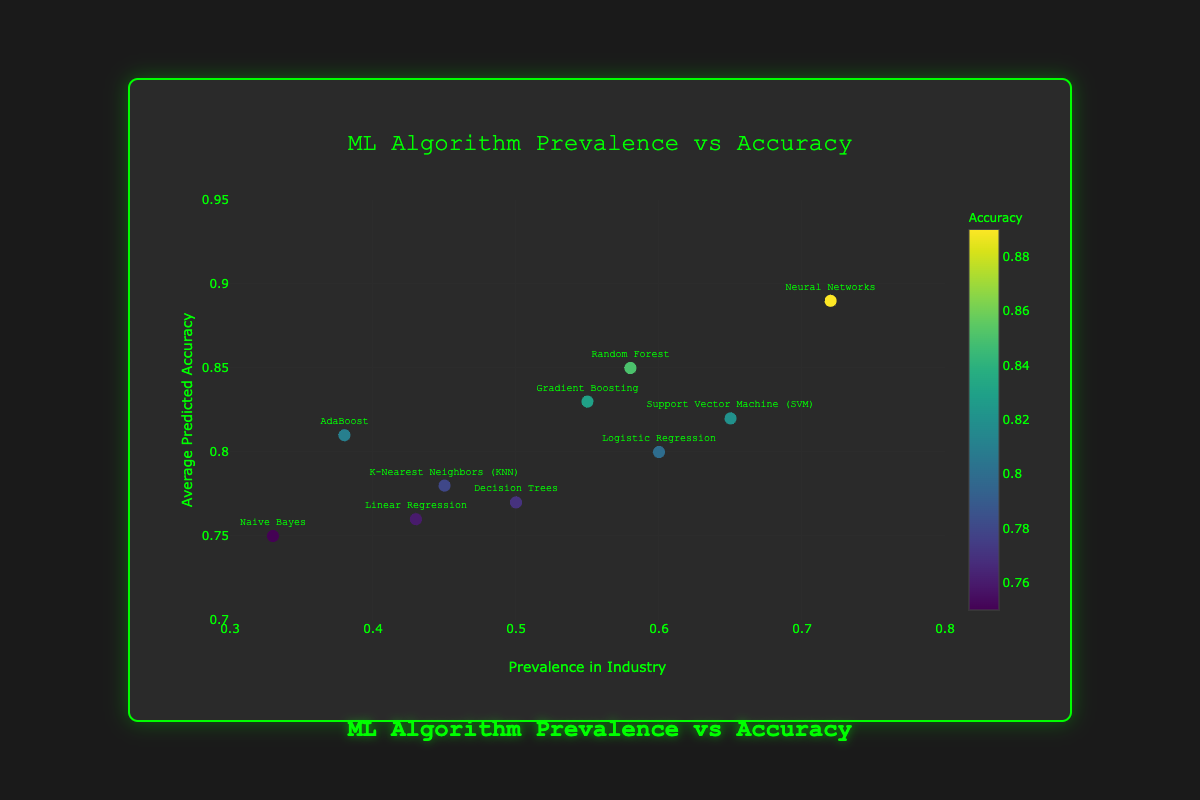What is the title of the scatter plot? The title of the scatter plot is located at the top center of the figure. It is styled in a font that matches the rest of the dataset.
Answer: ML Algorithm Prevalence vs Accuracy Which algorithm has the highest average predicted accuracy? The y-axis represents the average predicted accuracy. By identifying the highest point on the y-axis and reading its corresponding label, we can determine that Neural Networks have the highest average predicted accuracy.
Answer: Neural Networks What is the prevalence in the industry for Gradient Boosting? To answer this question, locate the point labeled "Gradient Boosting" and read its x-axis value.
Answer: 0.55 Which algorithm has both a prevalence in the industry greater than 0.60 and an average predicted accuracy greater than 0.80? Looking at the plot, find points where the x-values are greater than 0.60 and y-values are greater than 0.80. Only Neural Networks and Support Vector Machine (SVM) meet both conditions.
Answer: Neural Networks, Support Vector Machine (SVM) What is the difference in average predicted accuracy between Random Forest and Naive Bayes? Locate Random Forest and Naive Bayes on the plot and read their y-axis values. Subtract the lower value from the higher value: 0.85 - 0.75 = 0.10.
Answer: 0.10 Which algorithm is the least prevalent in the industry? Identify the point farthest to the left on the x-axis. This point corresponds to Naive Bayes.
Answer: Naive Bayes How many algorithms have an average predicted accuracy of 0.80 or higher? Count the data points that are above 0.80 on the y-axis. There are six data points that meet this criterion: Neural Networks, Random Forest, Gradient Boosting, Support Vector Machine (SVM), Logistic Regression, and AdaBoost.
Answer: Six Which algorithm has a higher prevalence in the industry: Decision Trees or K-Nearest Neighbors (KNN)? Locate Decision Trees and K-Nearest Neighbors (KNN) on the plot and compare their x-axis values. Decision Trees have a higher prevalence (0.50) than K-Nearest Neighbors (0.45).
Answer: Decision Trees What is the range of average predicted accuracies for these algorithms? The range is determined by subtracting the minimum value on the y-axis from the maximum value. The minimum accuracy is 0.75 (Naive Bayes) and the maximum is 0.89 (Neural Networks). So the range is 0.89 - 0.75 = 0.14.
Answer: 0.14 